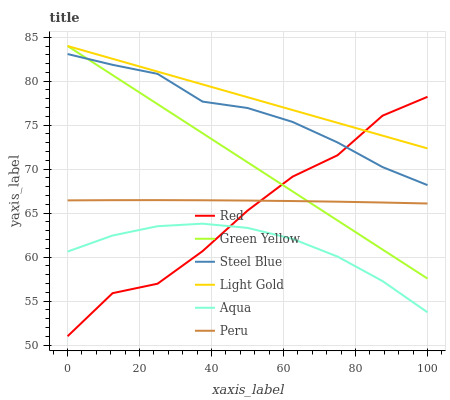Does Aqua have the minimum area under the curve?
Answer yes or no. Yes. Does Light Gold have the maximum area under the curve?
Answer yes or no. Yes. Does Steel Blue have the minimum area under the curve?
Answer yes or no. No. Does Steel Blue have the maximum area under the curve?
Answer yes or no. No. Is Green Yellow the smoothest?
Answer yes or no. Yes. Is Red the roughest?
Answer yes or no. Yes. Is Steel Blue the smoothest?
Answer yes or no. No. Is Steel Blue the roughest?
Answer yes or no. No. Does Red have the lowest value?
Answer yes or no. Yes. Does Steel Blue have the lowest value?
Answer yes or no. No. Does Light Gold have the highest value?
Answer yes or no. Yes. Does Steel Blue have the highest value?
Answer yes or no. No. Is Peru less than Light Gold?
Answer yes or no. Yes. Is Light Gold greater than Peru?
Answer yes or no. Yes. Does Green Yellow intersect Light Gold?
Answer yes or no. Yes. Is Green Yellow less than Light Gold?
Answer yes or no. No. Is Green Yellow greater than Light Gold?
Answer yes or no. No. Does Peru intersect Light Gold?
Answer yes or no. No. 